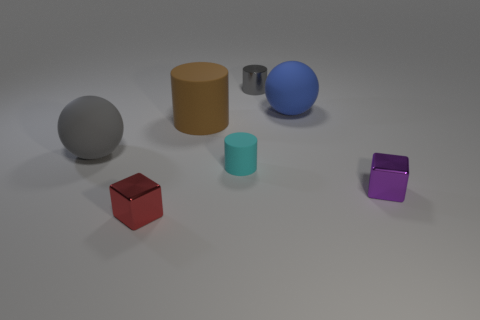Does the large ball left of the large brown matte object have the same color as the shiny cylinder?
Your response must be concise. Yes. Is the number of objects that are behind the tiny cyan rubber cylinder greater than the number of large cyan rubber balls?
Keep it short and to the point. Yes. Are there any other things that have the same color as the shiny cylinder?
Offer a terse response. Yes. There is a matte object to the left of the cube to the left of the brown thing; what shape is it?
Ensure brevity in your answer.  Sphere. Are there more large gray spheres than matte spheres?
Offer a very short reply. No. How many objects are both right of the large gray ball and behind the cyan matte object?
Your response must be concise. 3. There is a gray object to the right of the red thing; what number of tiny gray shiny objects are in front of it?
Provide a succinct answer. 0. How many objects are rubber things that are on the left side of the cyan thing or tiny objects behind the big gray rubber ball?
Keep it short and to the point. 3. There is a gray thing that is the same shape as the blue matte thing; what material is it?
Give a very brief answer. Rubber. How many objects are tiny metal things that are right of the large blue ball or gray matte cylinders?
Your answer should be compact. 1. 